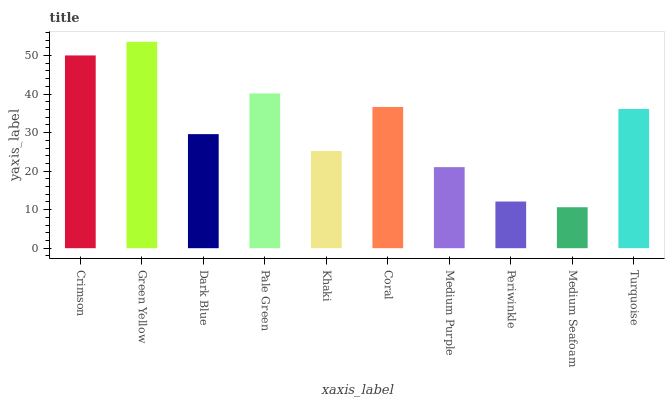Is Medium Seafoam the minimum?
Answer yes or no. Yes. Is Green Yellow the maximum?
Answer yes or no. Yes. Is Dark Blue the minimum?
Answer yes or no. No. Is Dark Blue the maximum?
Answer yes or no. No. Is Green Yellow greater than Dark Blue?
Answer yes or no. Yes. Is Dark Blue less than Green Yellow?
Answer yes or no. Yes. Is Dark Blue greater than Green Yellow?
Answer yes or no. No. Is Green Yellow less than Dark Blue?
Answer yes or no. No. Is Turquoise the high median?
Answer yes or no. Yes. Is Dark Blue the low median?
Answer yes or no. Yes. Is Dark Blue the high median?
Answer yes or no. No. Is Medium Purple the low median?
Answer yes or no. No. 